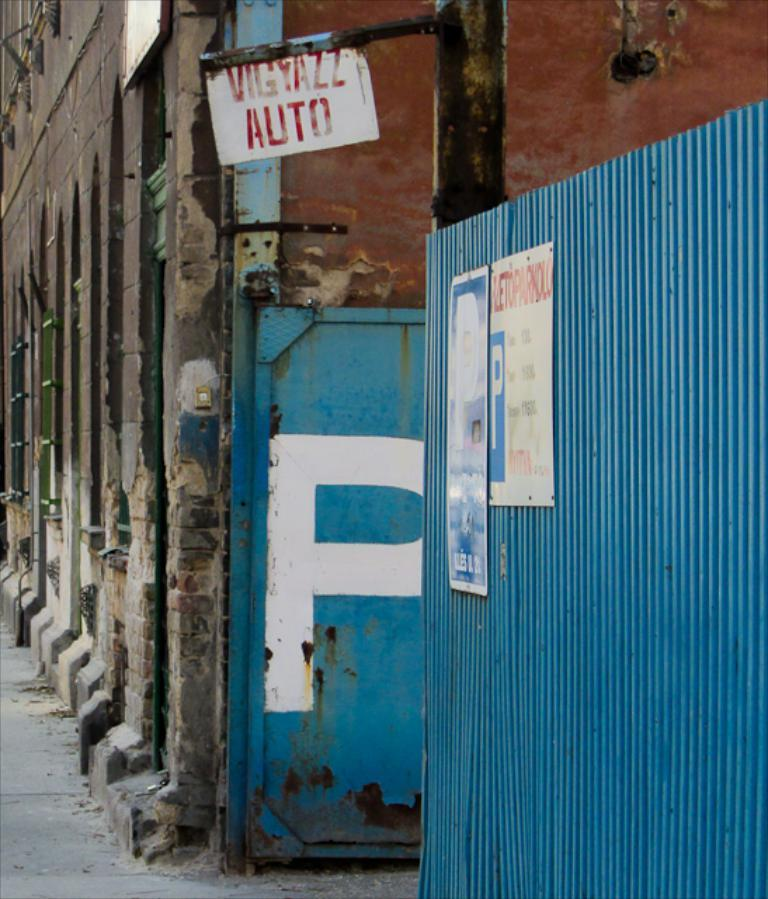What type of structure is visible in the image? There is a building in the image. What color is the sheet on the right side of the image? The sheet on the right side of the image is blue. How many boards are present in the image? There are three boards in the image. What can be found on the boards? There is text on the boards. Can you tell me the route the monkey takes to climb the building in the image? There is no monkey present in the image, so it is not possible to determine a route for climbing the building. 